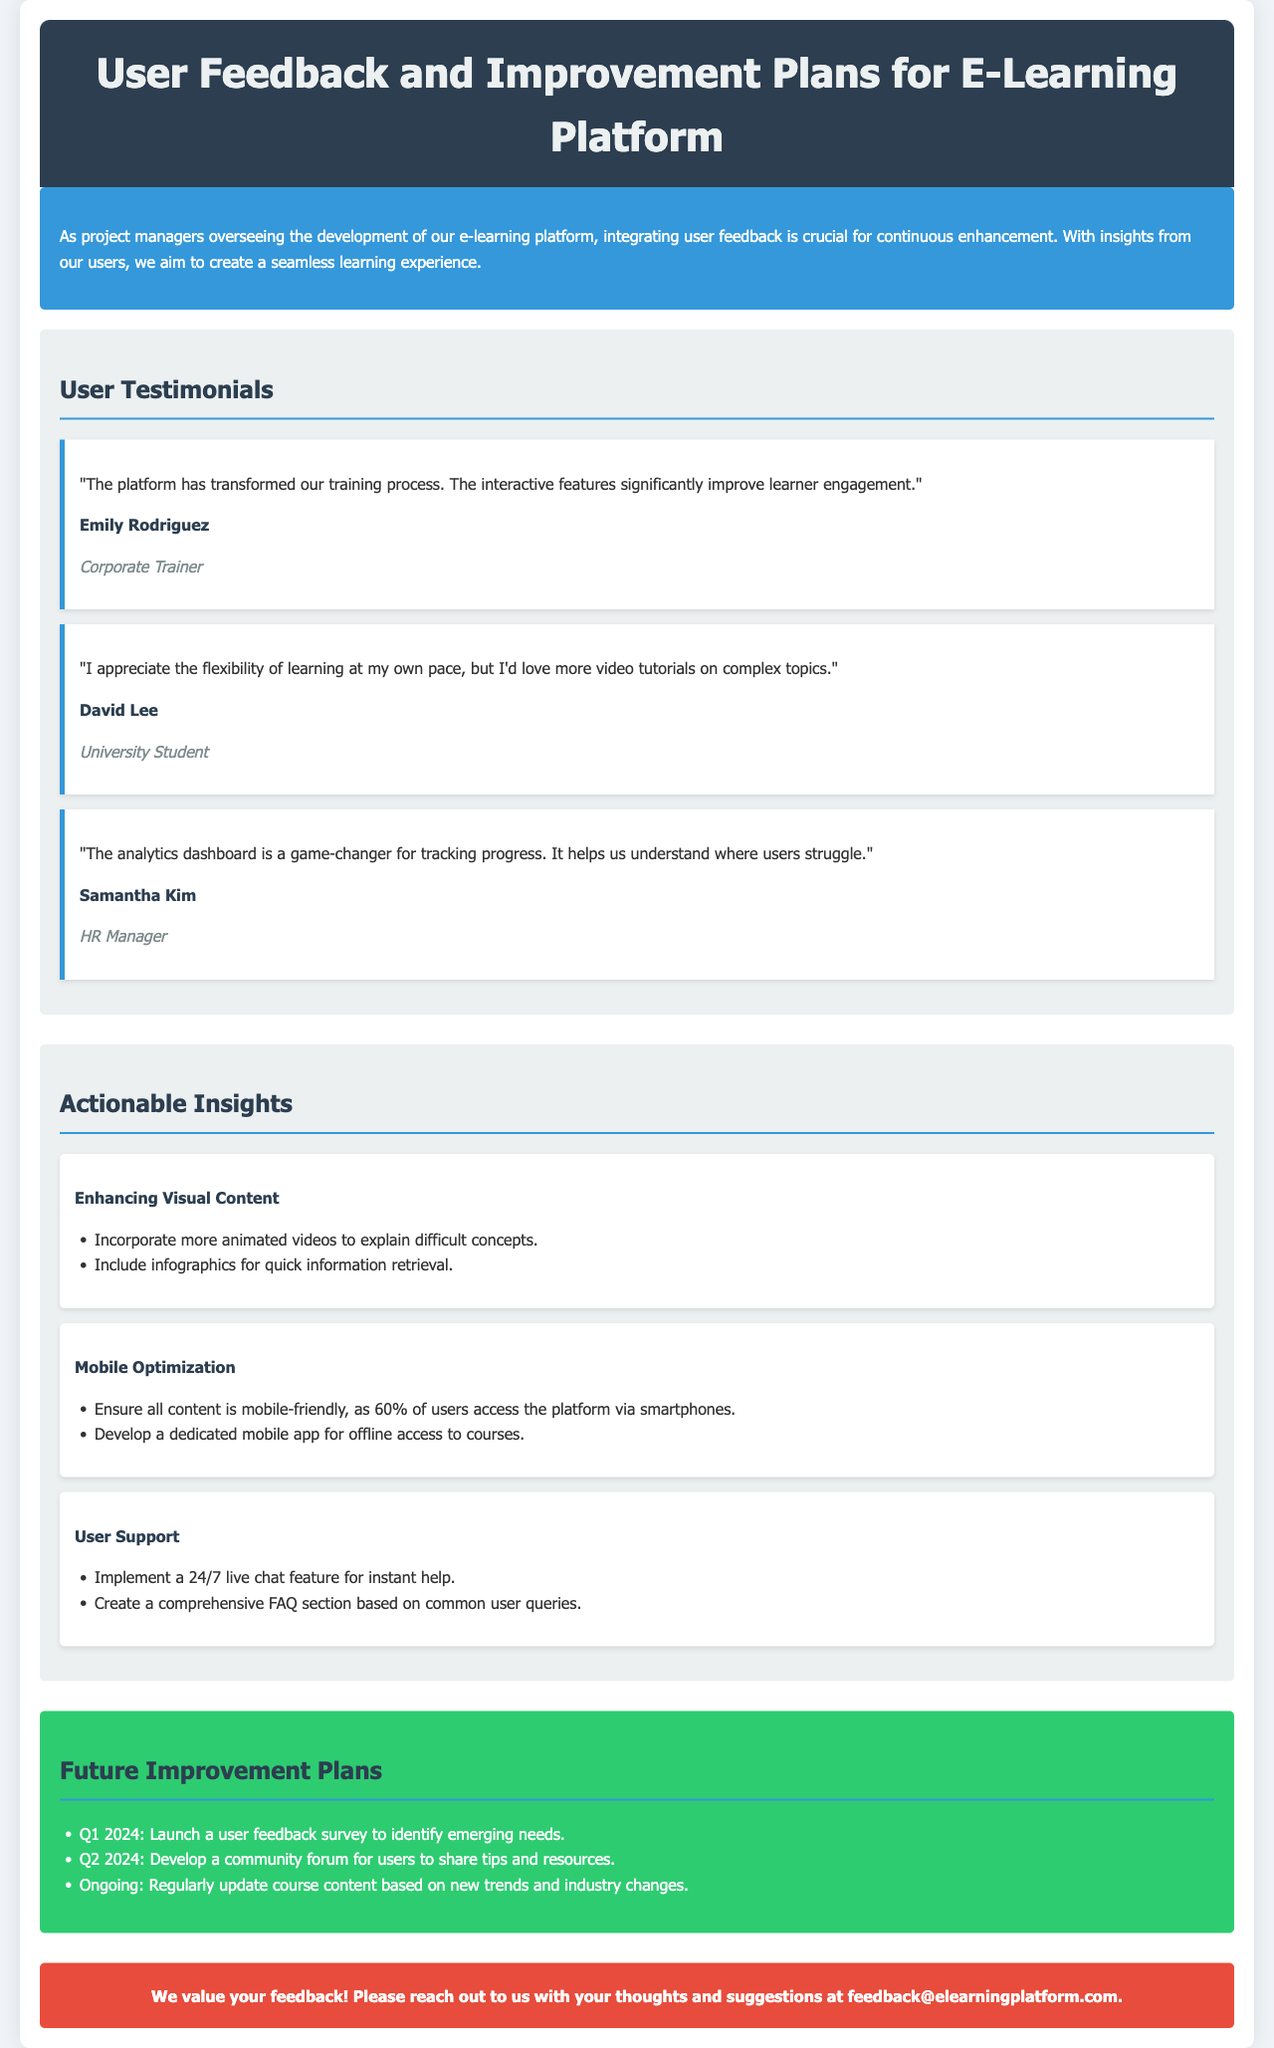What is the title of the document? The title is presented in the header section of the document.
Answer: User Feedback and Improvement Plans for E-Learning Platform Who provided feedback about the analytics dashboard? The name of the individual who mentioned the analytics dashboard is included in the testimonial section.
Answer: Samantha Kim What is the suggested feature for mobile users? The document discusses specific improvements for mobile usage which are listed in the insights.
Answer: Dedicated mobile app for offline access What is the percentage of users accessing the platform via smartphones? The document states this percentage in the context of mobile optimization insights.
Answer: 60% What is the planned timeline for launching a user feedback survey? The timeline for this specific plan is outlined in the future improvement plans section.
Answer: Q1 2024 Name one of the testimonials about learner engagement. The testimonials provide specific quotes regarding learner engagement and the platform's impact.
Answer: "The platform has transformed our training process." What color is used for the introductory section? The background color for this section is specified in the style section of the code.
Answer: Blue What type of support feature is proposed for users? The document includes actionable insights on user support, including specific features.
Answer: 24/7 live chat feature What is a common user suggestion for video content? User suggestions for video content are found in the testimonials and insights regarding improvement.
Answer: More video tutorials on complex topics 